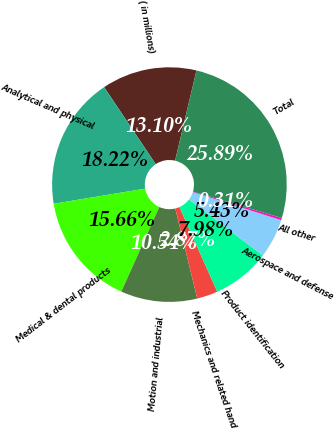Convert chart. <chart><loc_0><loc_0><loc_500><loc_500><pie_chart><fcel>( in millions)<fcel>Analytical and physical<fcel>Medical & dental products<fcel>Motion and industrial<fcel>Mechanics and related hand<fcel>Product identification<fcel>Aerospace and defense<fcel>All other<fcel>Total<nl><fcel>13.1%<fcel>18.22%<fcel>15.66%<fcel>10.54%<fcel>2.87%<fcel>7.98%<fcel>5.43%<fcel>0.31%<fcel>25.89%<nl></chart> 